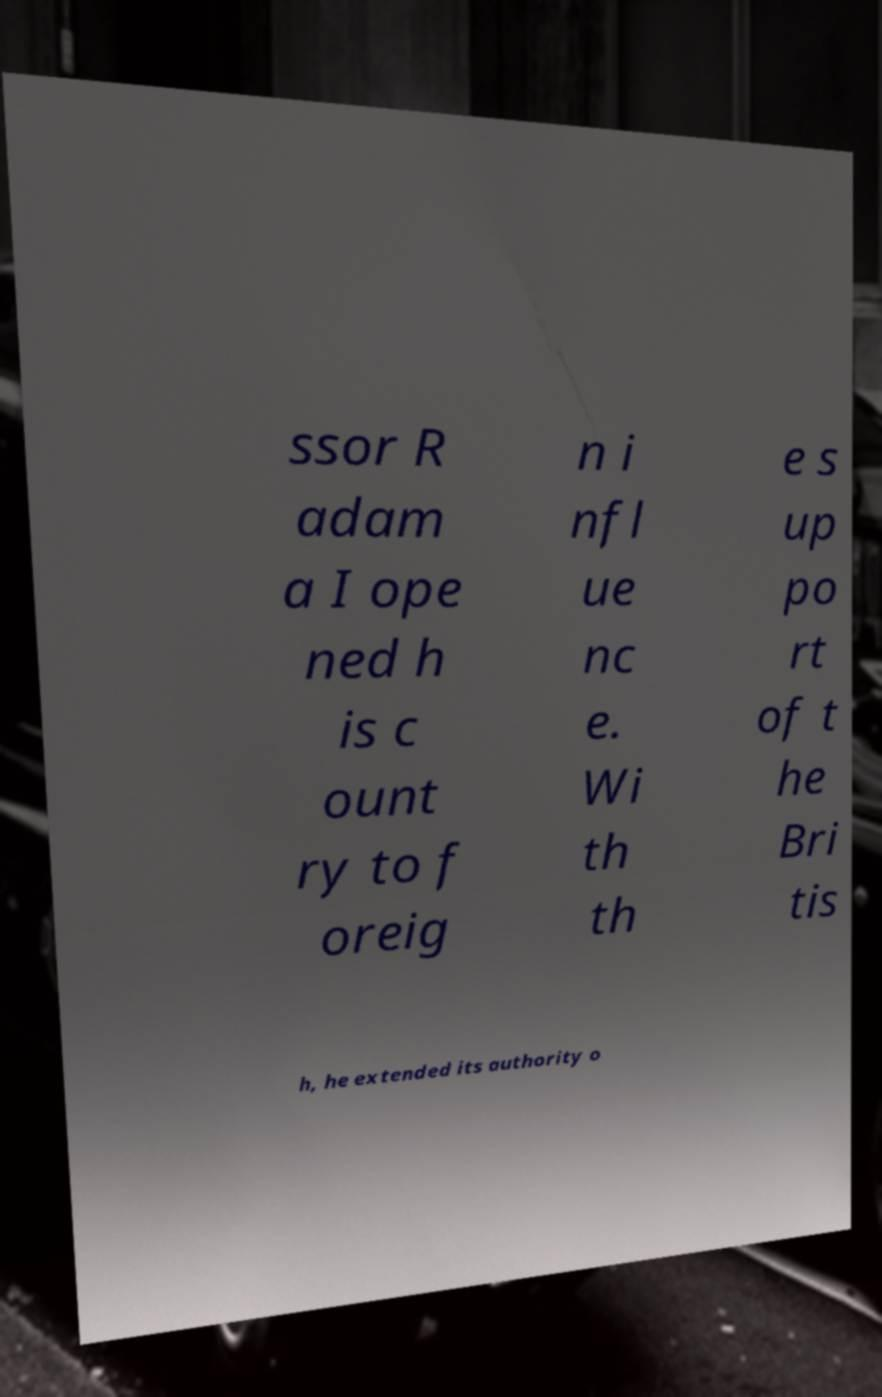For documentation purposes, I need the text within this image transcribed. Could you provide that? ssor R adam a I ope ned h is c ount ry to f oreig n i nfl ue nc e. Wi th th e s up po rt of t he Bri tis h, he extended its authority o 